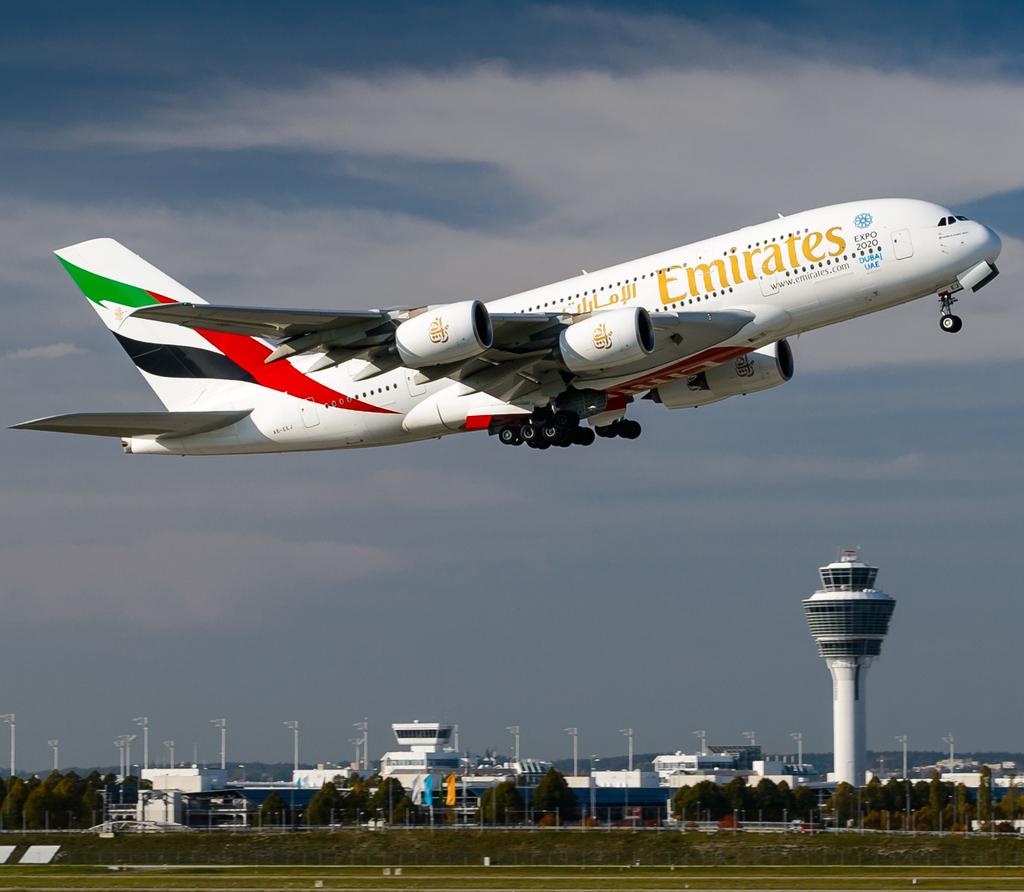What airline is this?
Ensure brevity in your answer.  Emirates. 